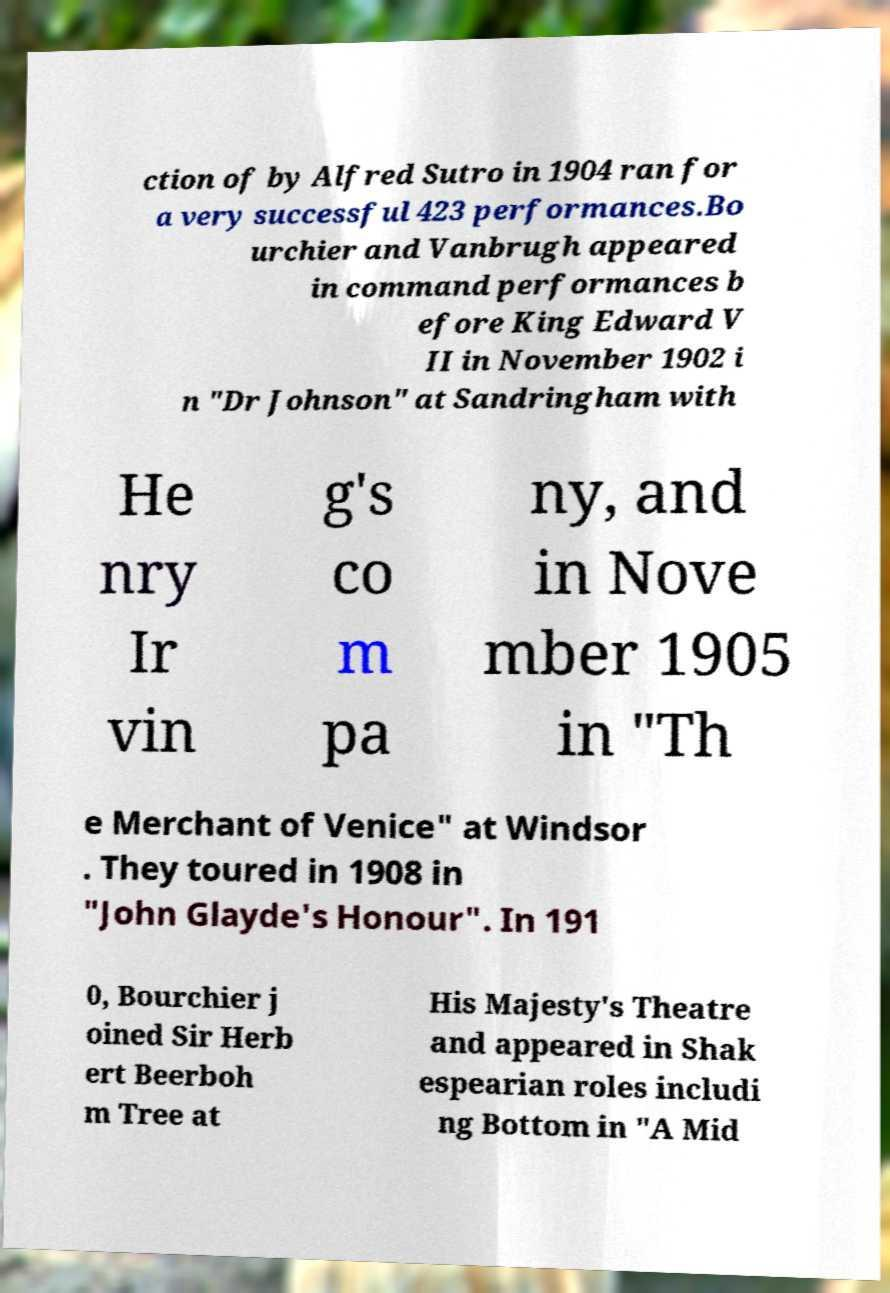Please read and relay the text visible in this image. What does it say? ction of by Alfred Sutro in 1904 ran for a very successful 423 performances.Bo urchier and Vanbrugh appeared in command performances b efore King Edward V II in November 1902 i n "Dr Johnson" at Sandringham with He nry Ir vin g's co m pa ny, and in Nove mber 1905 in "Th e Merchant of Venice" at Windsor . They toured in 1908 in "John Glayde's Honour". In 191 0, Bourchier j oined Sir Herb ert Beerboh m Tree at His Majesty's Theatre and appeared in Shak espearian roles includi ng Bottom in "A Mid 